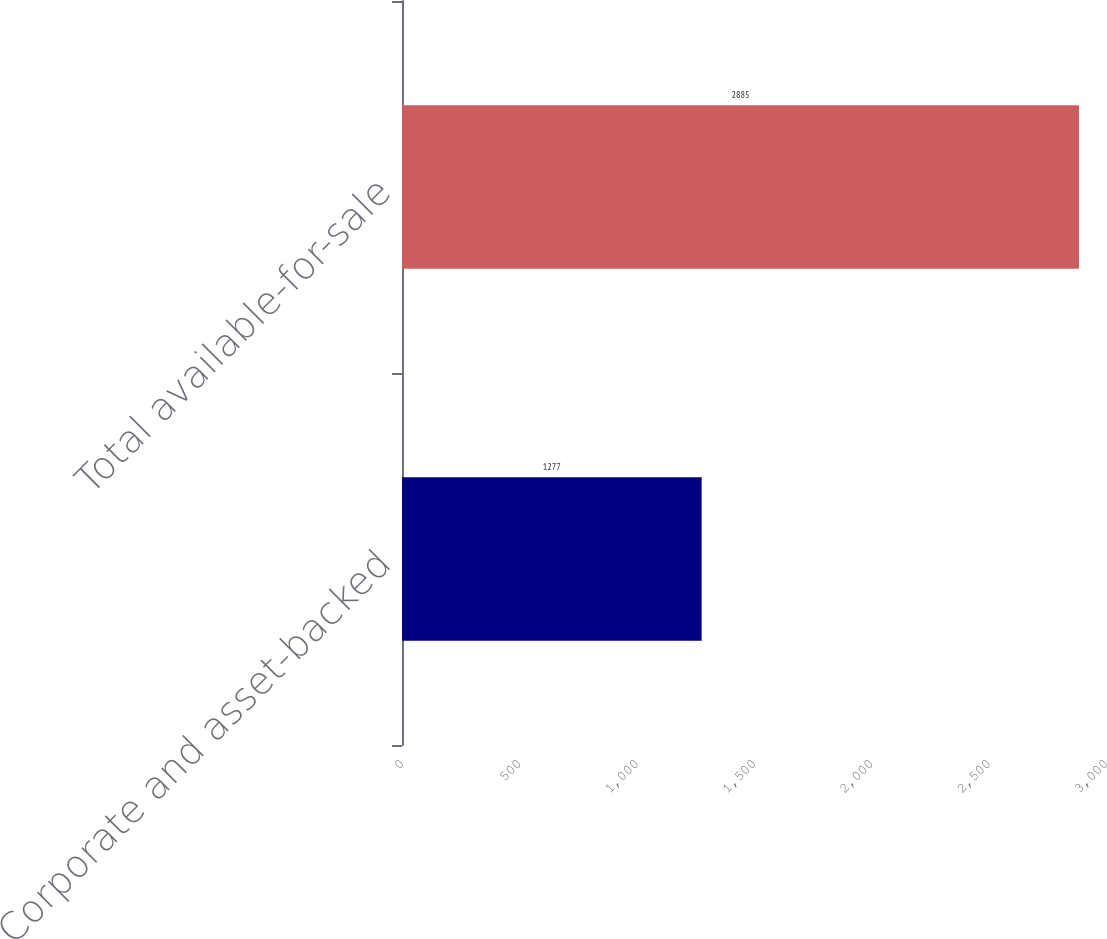<chart> <loc_0><loc_0><loc_500><loc_500><bar_chart><fcel>Corporate and asset-backed<fcel>Total available-for-sale<nl><fcel>1277<fcel>2885<nl></chart> 